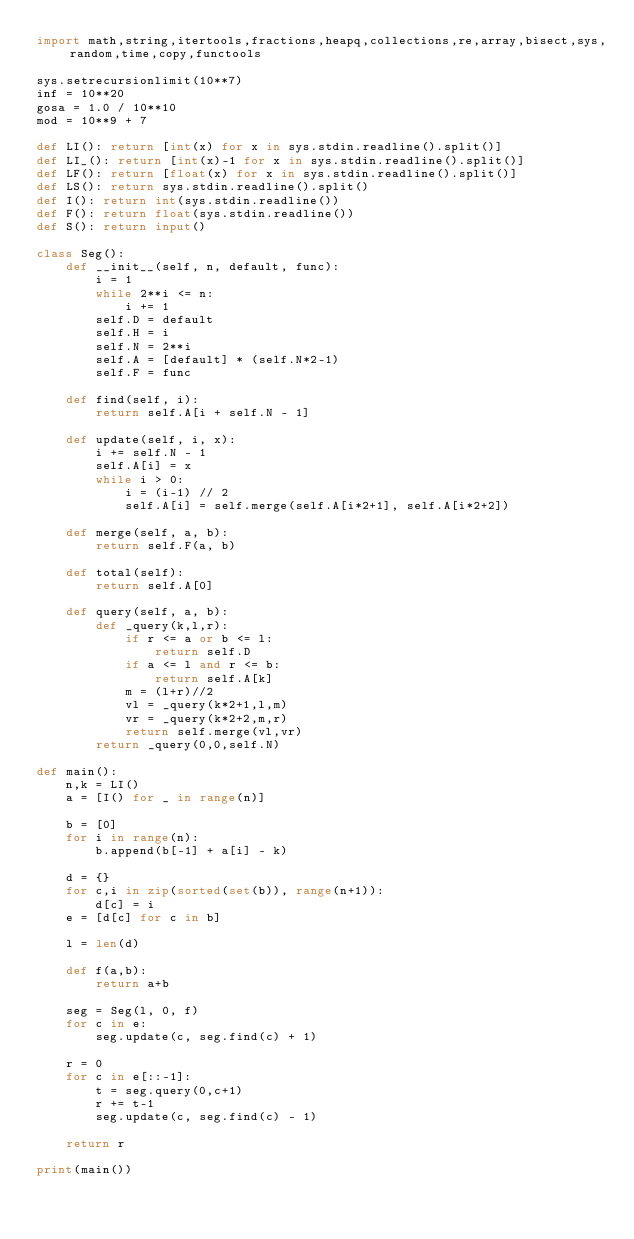Convert code to text. <code><loc_0><loc_0><loc_500><loc_500><_Python_>import math,string,itertools,fractions,heapq,collections,re,array,bisect,sys,random,time,copy,functools

sys.setrecursionlimit(10**7)
inf = 10**20
gosa = 1.0 / 10**10
mod = 10**9 + 7

def LI(): return [int(x) for x in sys.stdin.readline().split()]
def LI_(): return [int(x)-1 for x in sys.stdin.readline().split()]
def LF(): return [float(x) for x in sys.stdin.readline().split()]
def LS(): return sys.stdin.readline().split()
def I(): return int(sys.stdin.readline())
def F(): return float(sys.stdin.readline())
def S(): return input()

class Seg():
    def __init__(self, n, default, func):
        i = 1
        while 2**i <= n:
            i += 1
        self.D = default
        self.H = i
        self.N = 2**i
        self.A = [default] * (self.N*2-1)
        self.F = func

    def find(self, i):
        return self.A[i + self.N - 1]

    def update(self, i, x):
        i += self.N - 1
        self.A[i] = x
        while i > 0:
            i = (i-1) // 2
            self.A[i] = self.merge(self.A[i*2+1], self.A[i*2+2])

    def merge(self, a, b):
        return self.F(a, b)

    def total(self):
        return self.A[0]

    def query(self, a, b):
        def _query(k,l,r):
            if r <= a or b <= l:
                return self.D
            if a <= l and r <= b:
                return self.A[k]
            m = (l+r)//2
            vl = _query(k*2+1,l,m)
            vr = _query(k*2+2,m,r)
            return self.merge(vl,vr)
        return _query(0,0,self.N)

def main():
    n,k = LI()
    a = [I() for _ in range(n)]

    b = [0]
    for i in range(n):
        b.append(b[-1] + a[i] - k)

    d = {}
    for c,i in zip(sorted(set(b)), range(n+1)):
        d[c] = i
    e = [d[c] for c in b]

    l = len(d)

    def f(a,b):
        return a+b

    seg = Seg(l, 0, f)
    for c in e:
        seg.update(c, seg.find(c) + 1)

    r = 0
    for c in e[::-1]:
        t = seg.query(0,c+1)
        r += t-1
        seg.update(c, seg.find(c) - 1)

    return r

print(main())

</code> 